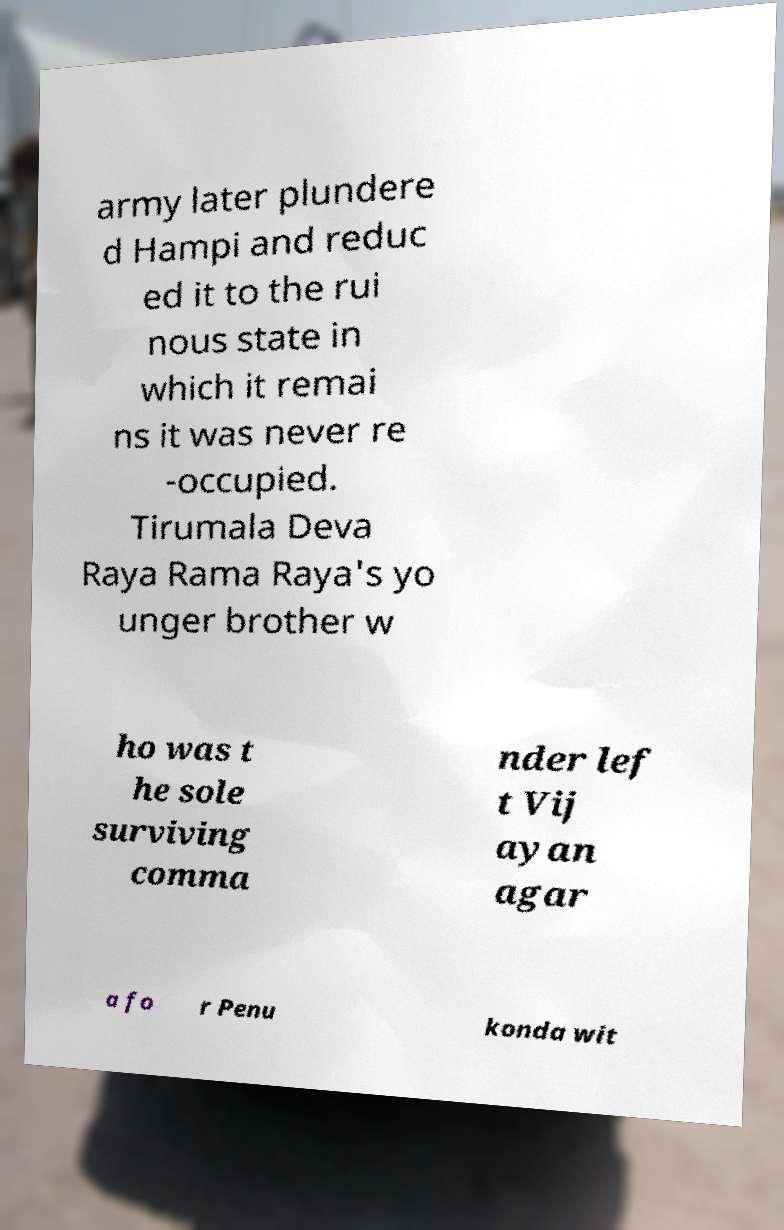Can you read and provide the text displayed in the image?This photo seems to have some interesting text. Can you extract and type it out for me? army later plundere d Hampi and reduc ed it to the rui nous state in which it remai ns it was never re -occupied. Tirumala Deva Raya Rama Raya's yo unger brother w ho was t he sole surviving comma nder lef t Vij ayan agar a fo r Penu konda wit 